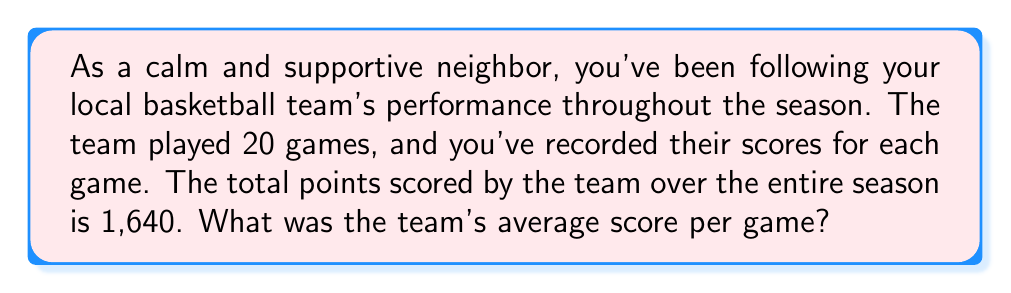Give your solution to this math problem. To find the average score per game, we need to use the formula for calculating the arithmetic mean:

$$ \text{Average} = \frac{\text{Sum of all values}}{\text{Number of values}} $$

In this case:
- The sum of all values is the total points scored over the season: 1,640
- The number of values is the number of games played: 20

Let's plug these values into our formula:

$$ \text{Average score per game} = \frac{1,640}{20} $$

Now, we simply need to perform the division:

$$ \text{Average score per game} = 82 $$

Therefore, the team's average score per game over the season was 82 points.
Answer: $82$ points per game 